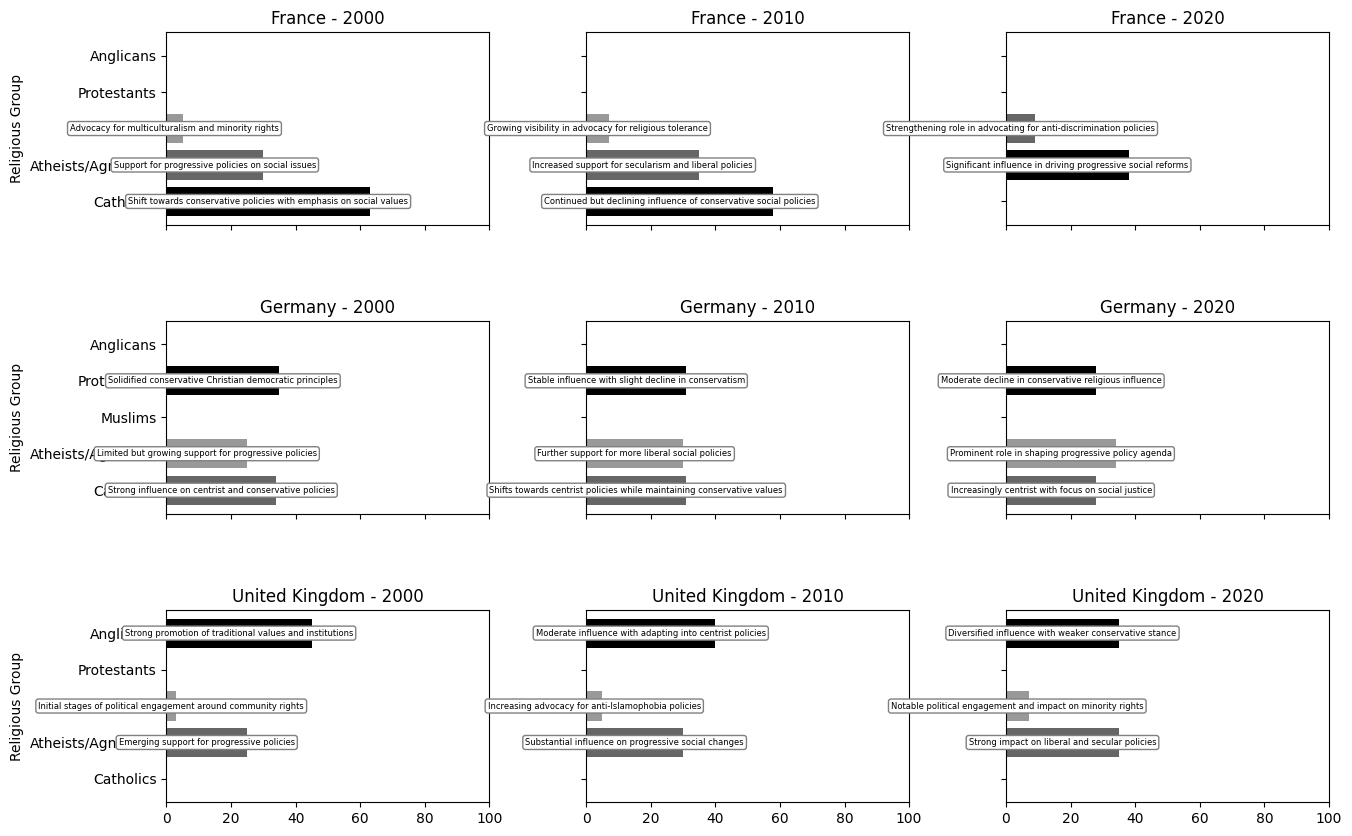What is the trend of the Catholic population in France from 2000 to 2020? Start by identifying the percentage of Catholics in France in 2000 (63%), 2010 (58%), and 2020 (not present in the last recorded year). Note the decreasing percentages over the years.
Answer: Decreasing Which religious group had the most significant numerical increase in the percentage of the population in Germany between 2000 and 2020? Identify the percentages of each religious group in Germany in 2000 and 2020. Calculate the difference for each group: Protestants (35%-28%= -7%), Catholics (34%-28%= -6%), Atheists/Agnostics (34%-25%= 9%). The largest increase is in Atheists/Agnostics.
Answer: Atheists/Agnostics In 2020, which country had the highest percentage of Muslims? Compare the 2020 percentages of the Muslim population in France (9%), Germany (no data for Muslims), and the United Kingdom (7%). France has the highest percentage.
Answer: France How did the percentage of Anglicans in the United Kingdom change from 2000 to 2020? Identify the percentage of Anglicans in the UK in 2000 (45%), 2010 (40%), and 2020 (35%). Note the decreasing trend over the years.
Answer: Decreasing Between 2000 and 2020, what shift occurred in the political ideology impact of Atheists/Agnostics in France? Review the political ideology impacts for Atheists/Agnostics in France in 2000 (support for progressive policies), 2010 (increased support for secularism and liberal policies), and 2020 (significant influence in driving progressive social reforms). Identify the growing influence and movement towards progressive reforms.
Answer: Increased influence on progressive reforms What was the average percentage of the Catholic population in Germany across the given years? List the percentages of the Catholic population in Germany in 2000 (34%), 2010 (31%), and 2020 (28%). Sum these percentages (34 + 31 + 28 = 93) and divide by the number of years (93/3 ≈ 31).
Answer: 31% Are atheists/agnostics more prominent in France, Germany, or the United Kingdom in 2020? Compare the percentages of atheists/agnostics in each country in 2020: France (38%), Germany (34%), and United Kingdom (35%). France has the highest percentage.
Answer: France Which country witnessed an increase in the Muslim population by 2% from 2000 to 2010? Identify the initial and subsequent percentages of Muslims in each country and compare the increases: France (5% to 7%), United Kingdom (3% to 5%). Both countries had a 2% increase.
Answer: France and United Kingdom What trend is observed in the percentage of Protestants in Germany from 2000 to 2020? Identify the percentage of Protestants in Germany in 2000 (35%), 2010 (31%), and 2020 (28%). Note the decreasing trend over the years.
Answer: Decreasing 